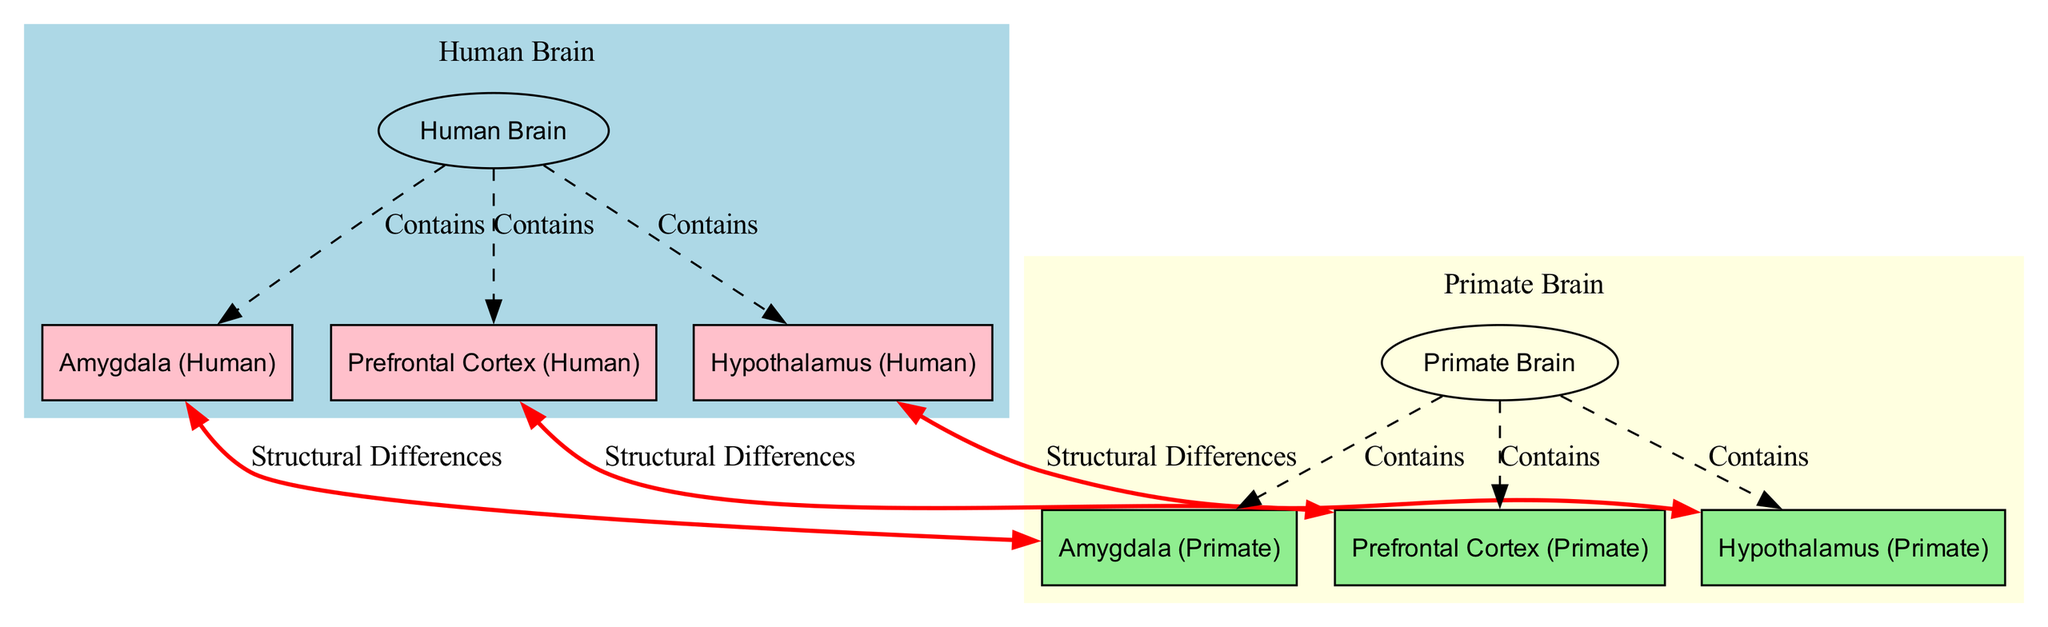What is the color of the Human Brain region? The Human Brain region is represented in light blue. This can be identified from the diagram where the label for the Human Brain is filled with light blue shading.
Answer: light blue How many emotional processing regions are shown for the Primate Brain? There are three emotional processing regions indicated for the Primate Brain: the Amygdala, Prefrontal Cortex, and Hypothalamus. This can be determined by counting the nodes that are designated for the Primate Brain and belong to the emotional processing group.
Answer: three What connection type is shown between the Human Amygdala and Primate Amygdala? The connection type between the Human Amygdala and Primate Amygdala is categorized as "Structural Differences". This label can be identified on the red bi-directional edge connecting the two nodes.
Answer: Structural Differences Which human brain region is structurally compared to the Primate Hypothalamus? The region compared to the Primate Hypothalamus is the Hypothalamus (Human). This relationship can be seen in the corresponding edge labeled "Structural Differences" that links the Human and Primate Hypothalamus nodes.
Answer: Hypothalamus (Human) What is the total number of nodes representing regions in the Human Brain? The total number of nodes representing regions in the Human Brain is four, which includes the Human Brain, Amygdala (Human), Prefrontal Cortex (Human), and Hypothalamus (Human) nodes. These nodes can be counted directly from the visual representation in the diagram.
Answer: four Why might the Prefrontal Cortex regions be highlighted in different colors? The Prefrontal Cortex (Human) is highlighted in pink while the Prefrontal Cortex (Primate) is highlighted in light green, indicating their respective categorization under emotional processing within their brain structures. This color coding emphasizes the differences in structural composition between the two species' Prefrontal Cortex regions.
Answer: to indicate structural differences How many edges are present in the comparison section of the diagram? There are three edges present in the comparison section, which links the respective emotional processing structures between human and primate brains. These can be traced from the labeled edges that represent structural differences between similar regions.
Answer: three 